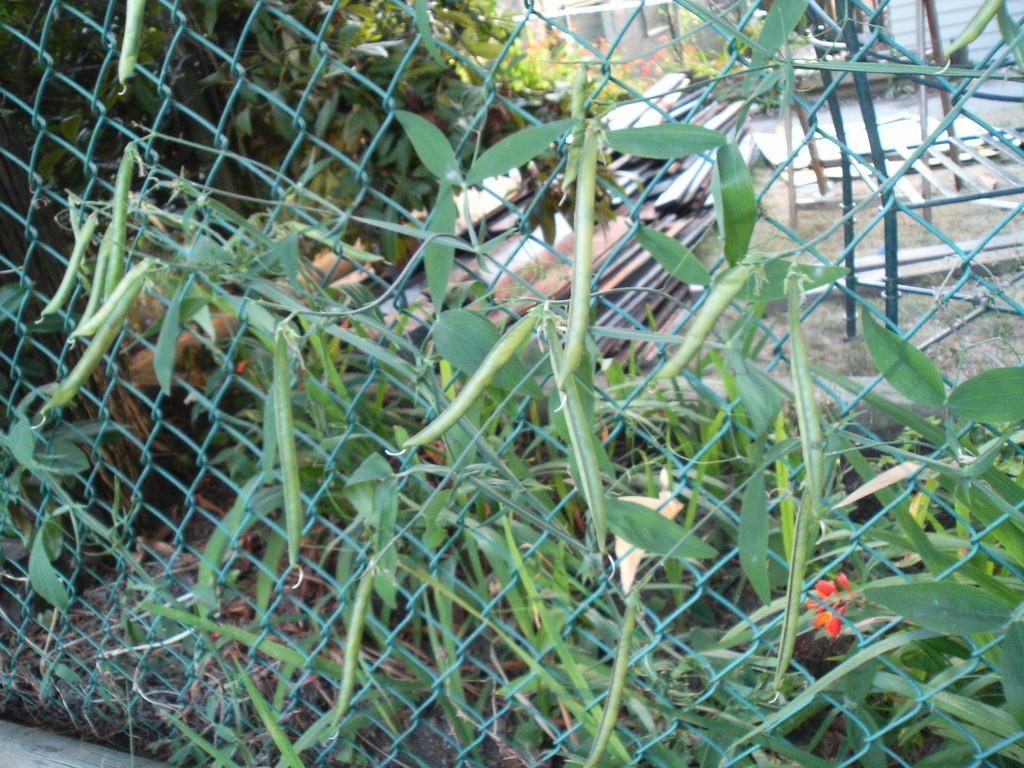Describe this image in one or two sentences. In the image I can see plants, fence, metal objects and some other objects on the ground. 